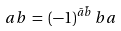Convert formula to latex. <formula><loc_0><loc_0><loc_500><loc_500>a b \, = \, ( - 1 ) ^ { \bar { a } \bar { b } } \, b a</formula> 